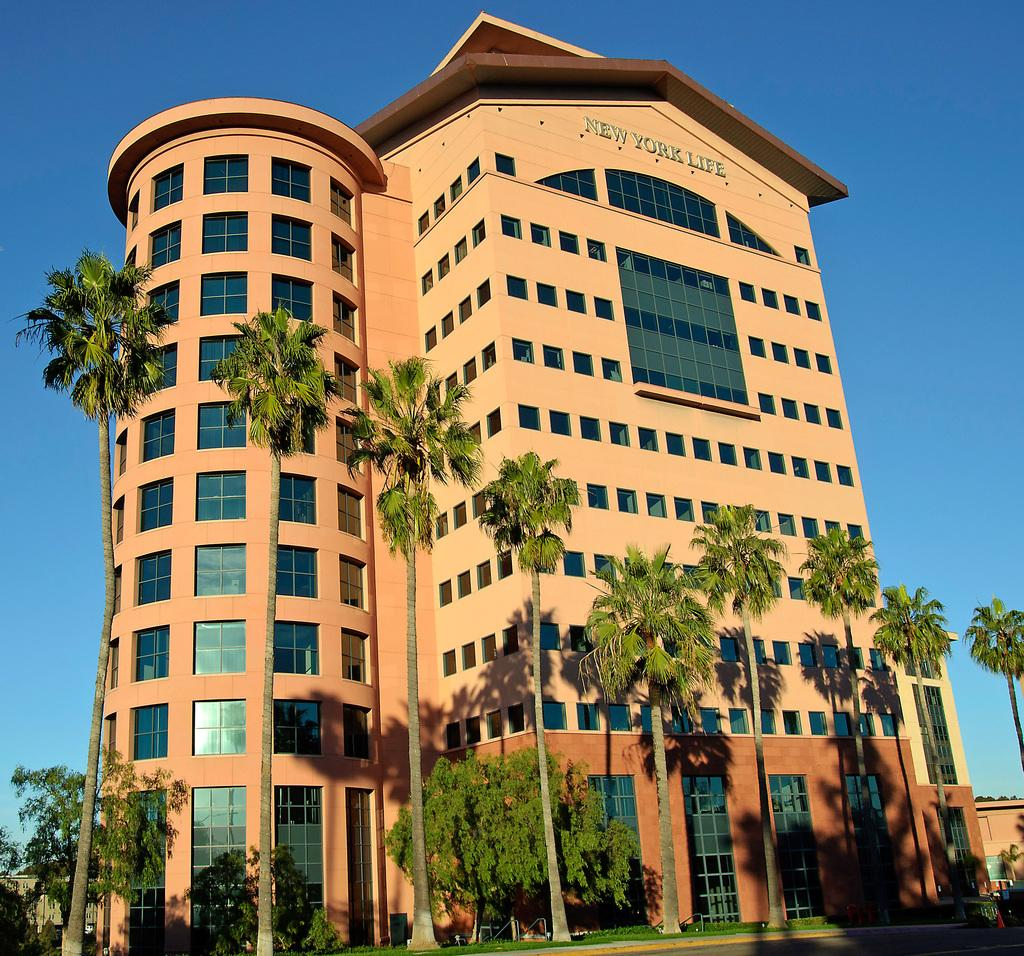What type of structure is present in the image? There is a building in the image. What can be seen in the background of the image? There are many trees and a grassy land in the image. What is visible at the top of the image? The sky is visible in the image. Is there any text or writing on the building? Yes, there is some text on the building. Where is the party happening in the image? There is no party happening in the image; it only shows a building, trees, grassy land, and the sky. Can you see a bottle in the image? There is no bottle present in the image. 